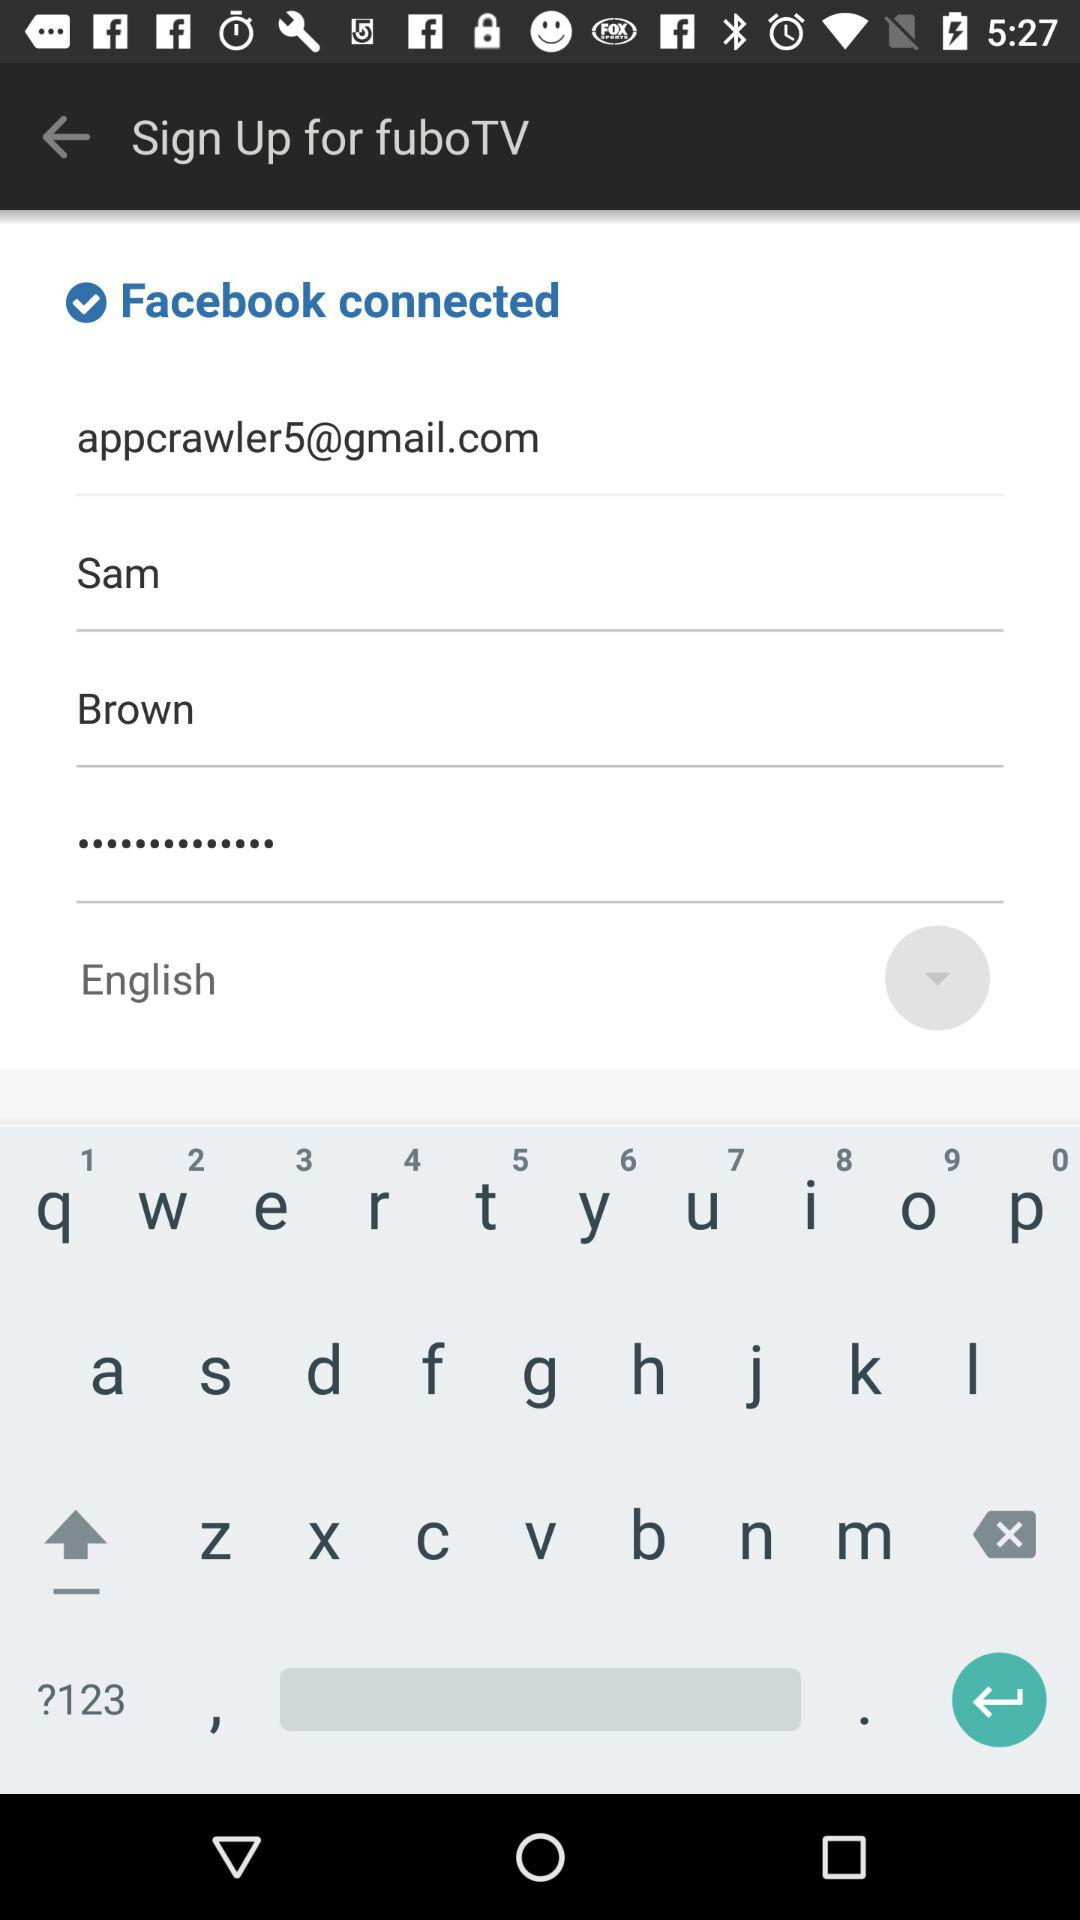Which language is selected? The selected language is English. 